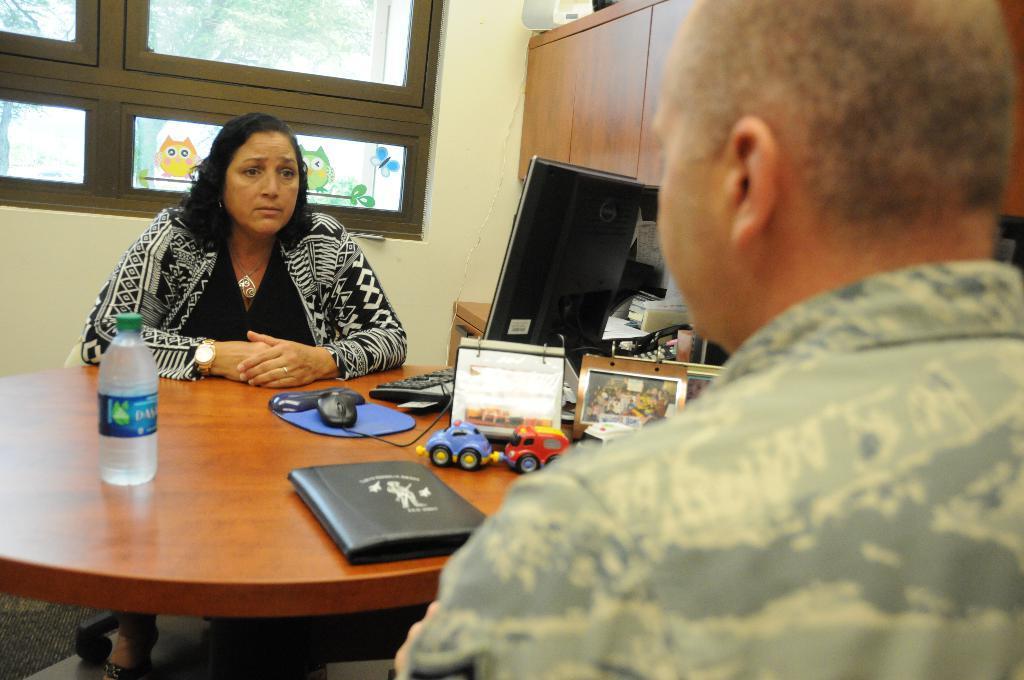How would you summarize this image in a sentence or two? Here we can see a woman and a man sitting on the chairs. This is table. On the table there is a bottle, file, to, monitor, keyboard, and a mouse. On the background there is a wall and this is window. From the glass we can see trees. And this is cupboard. 